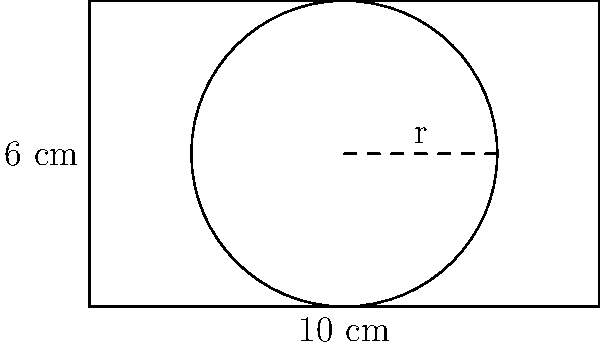You're designing packaging for a new circular product with a diameter of 6 cm. The packaging needs to be rectangular for efficient stacking. If the length of the rectangular box is 10 cm, what is the minimum width required to ensure the product fits snugly, maximizing space efficiency? Round your answer to the nearest centimeter. To solve this problem, we need to follow these steps:

1. Identify the key information:
   - The product is circular with a diameter of 6 cm
   - The packaging is rectangular
   - The length of the box is 10 cm

2. Determine the radius of the circular product:
   $$\text{radius} = \frac{\text{diameter}}{2} = \frac{6 \text{ cm}}{2} = 3 \text{ cm}$$

3. Recognize that the width of the box must be at least equal to the diameter of the product:
   $$\text{minimum width} = \text{diameter} = 6 \text{ cm}$$

4. Round the result to the nearest centimeter:
   The minimum width of 6 cm is already a whole number, so no rounding is necessary.

5. Verify that this width allows the product to fit snugly:
   With a width of 6 cm, the circular product will touch both sides of the box, ensuring a snug fit and maximizing space efficiency.
Answer: 6 cm 